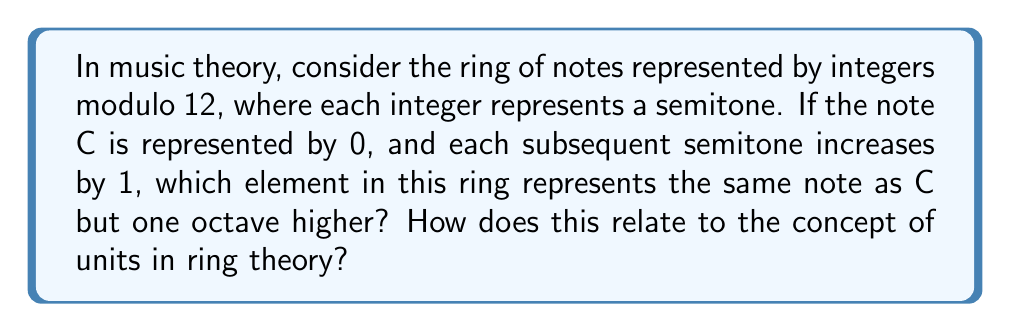Could you help me with this problem? To solve this problem, let's break it down step-by-step:

1) In the ring of integers modulo 12, we have:
   $$\mathbb{Z}_{12} = \{0, 1, 2, 3, 4, 5, 6, 7, 8, 9, 10, 11\}$$

2) Each element represents a note:
   0 = C, 1 = C#, 2 = D, ..., 11 = B

3) An octave in music consists of 12 semitones. So, to go up one octave from C (0), we need to add 12 semitones:
   $$0 + 12 \equiv 0 \pmod{12}$$

4) This means that in this ring, 0 and 12 represent the same element, which musically translates to C and C (one octave higher) being the same note class.

5) In ring theory, a unit is an element that has a multiplicative inverse. In $\mathbb{Z}_{12}$, the units are the elements that are coprime to 12:
   $$U(\mathbb{Z}_{12}) = \{1, 5, 7, 11\}$$

6) Musically, multiplying by a unit in this ring corresponds to a transposition that preserves the intervallic structure. For example:
   $$5 \cdot 0 \equiv 0 \pmod{12}$$
   $$5 \cdot 1 \equiv 5 \pmod{12}$$
   $$5 \cdot 2 \equiv 10 \pmod{12}$$
   This represents a perfect fourth transposition (C to F, C# to F#, D to G#, etc.)

7) The fact that multiplying by a unit always results in a one-to-one mapping of the elements in the ring corresponds musically to the fact that these transpositions preserve the structural relationships between notes, just in a different key.
Answer: The element 0 in $\mathbb{Z}_{12}$ represents C one octave higher. This illustrates how the cyclic nature of the ring mirrors the cyclic nature of octaves in music. The units of the ring ($1, 5, 7, 11$) correspond to musical transpositions that preserve intervallic relationships, demonstrating how ring theory can model fundamental aspects of musical structure. 